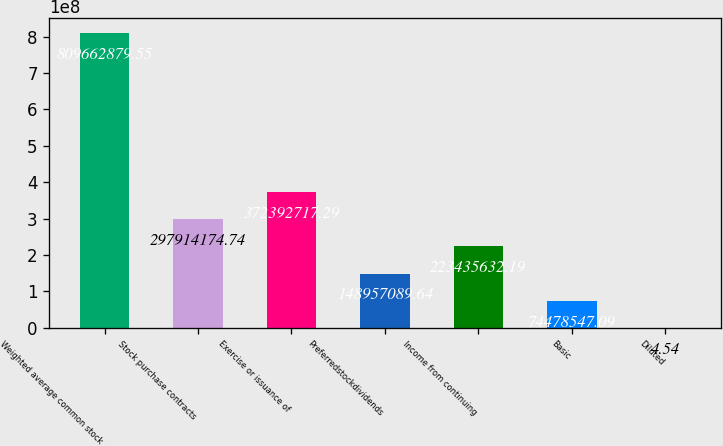<chart> <loc_0><loc_0><loc_500><loc_500><bar_chart><fcel>Weighted average common stock<fcel>Stock purchase contracts<fcel>Exercise or issuance of<fcel>Preferredstockdividends<fcel>Income from continuing<fcel>Basic<fcel>Diluted<nl><fcel>8.09663e+08<fcel>2.97914e+08<fcel>3.72393e+08<fcel>1.48957e+08<fcel>2.23436e+08<fcel>7.44785e+07<fcel>4.54<nl></chart> 